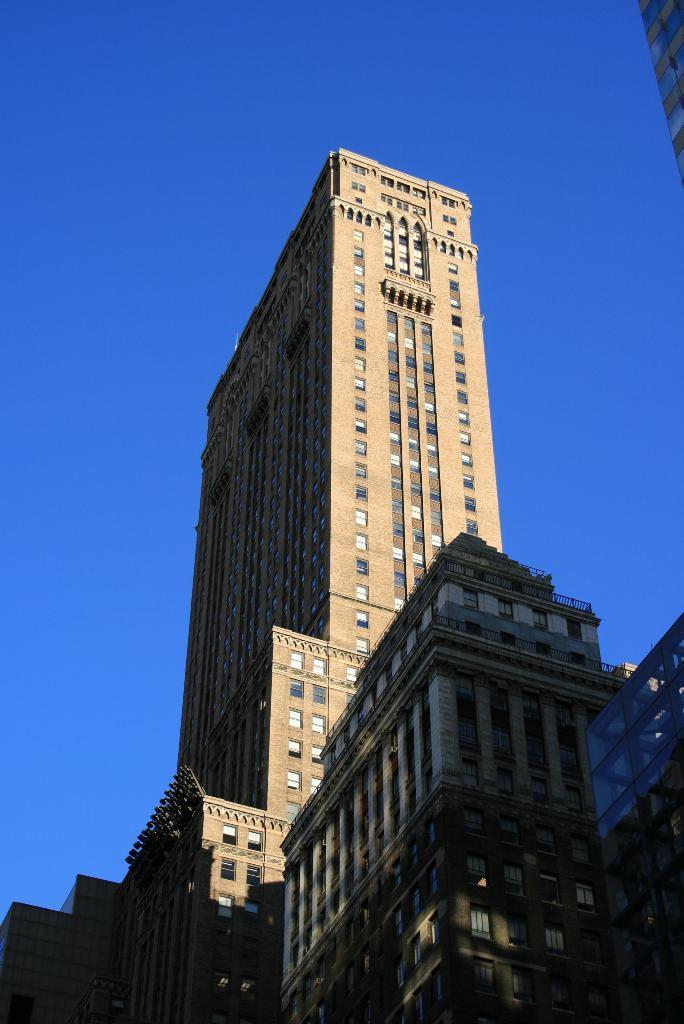Describe this image in one or two sentences. These are the very big buildings, at the top it is the sky. 